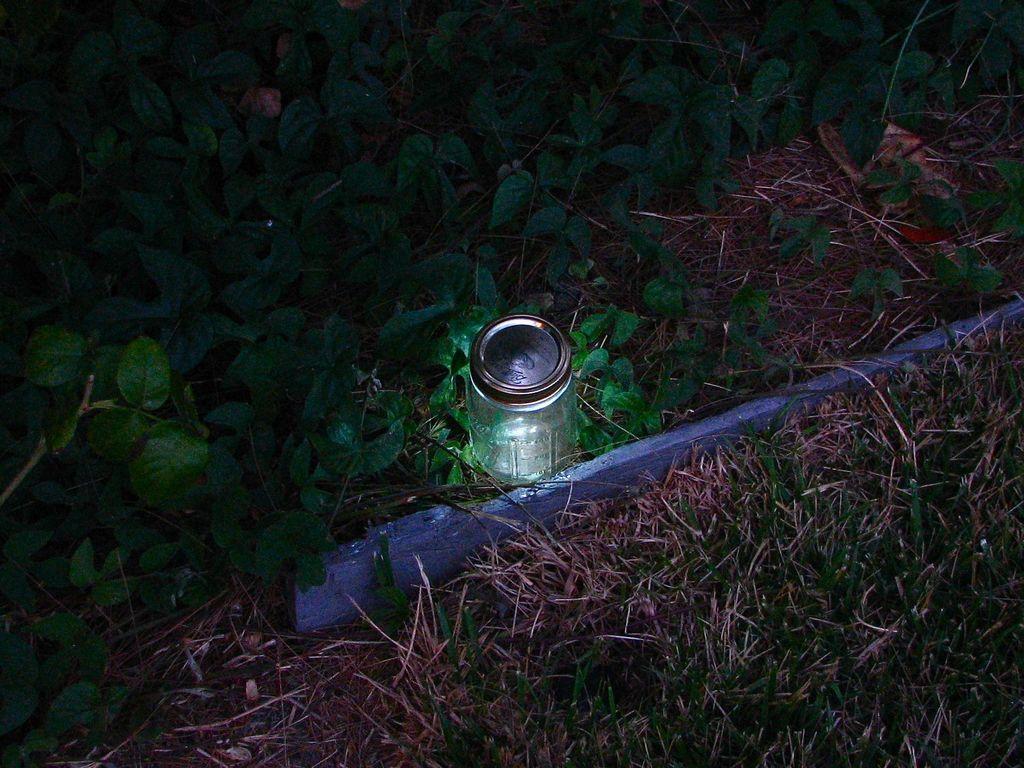Could you give a brief overview of what you see in this image? In this image i can see a glass and a plant. 